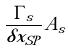Convert formula to latex. <formula><loc_0><loc_0><loc_500><loc_500>\frac { \Gamma _ { s } } { \delta x _ { S P } } A _ { s }</formula> 